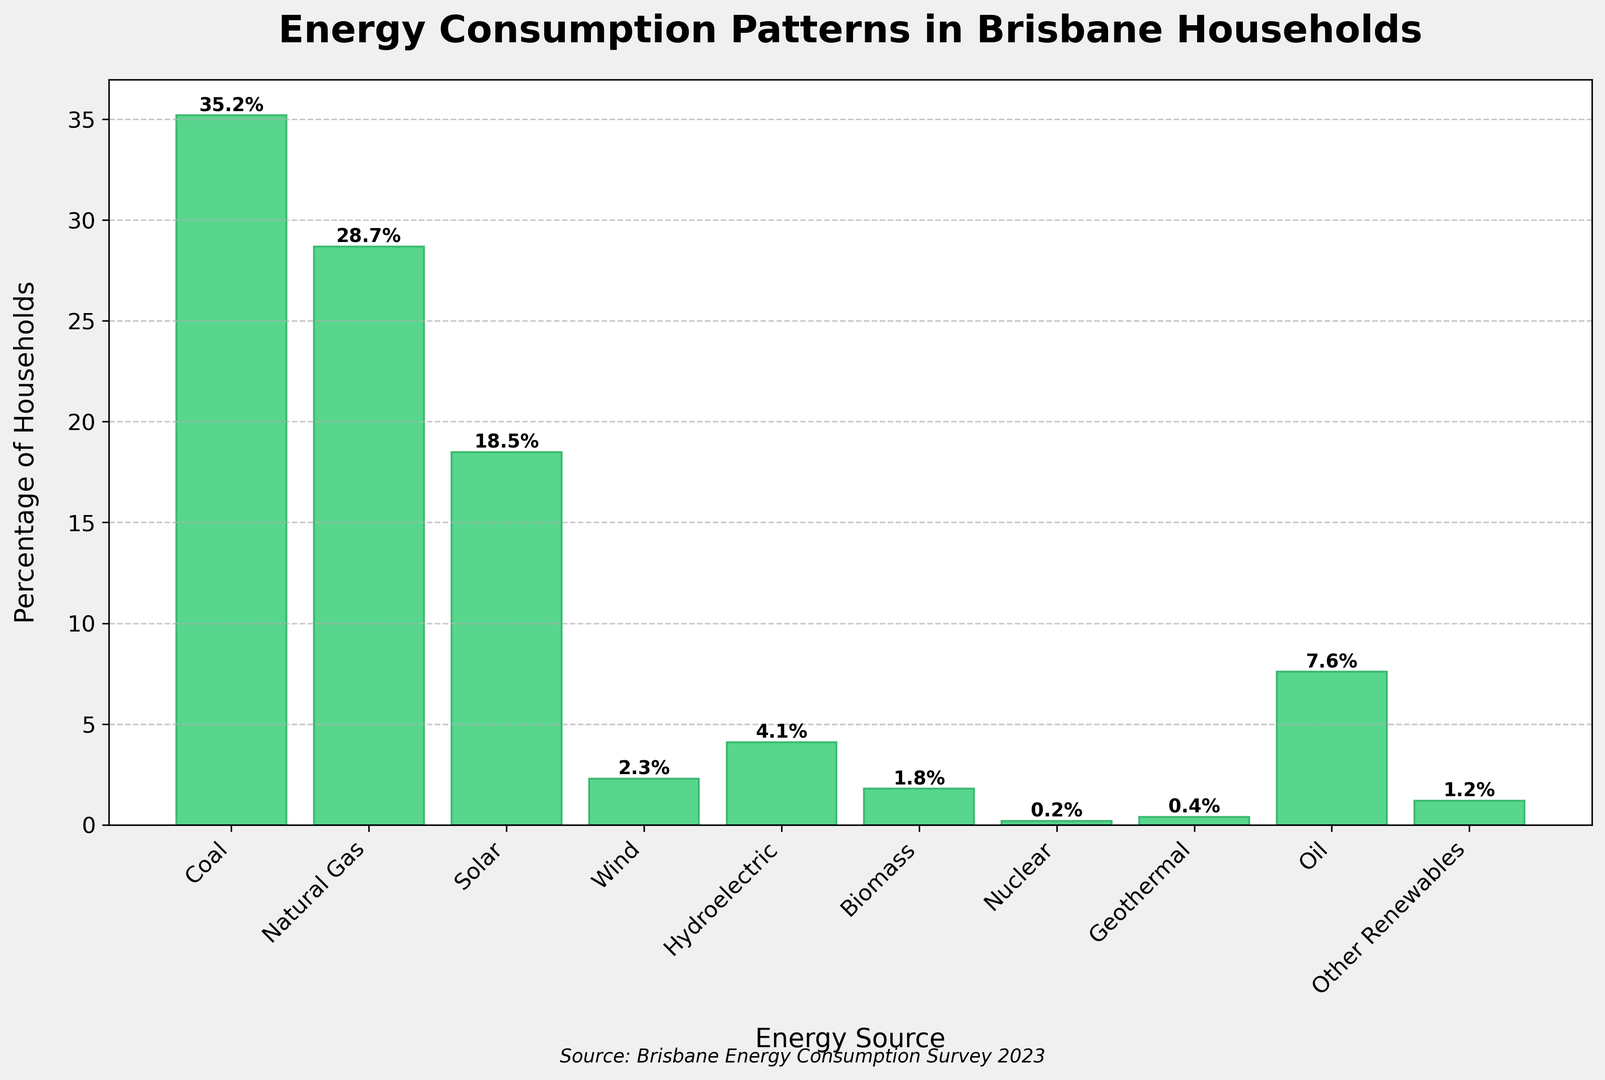Which source has the highest percentage of households? The source with the highest bar in the histogram represents the highest percentage of households. By looking at the graph, coal has the highest bar.
Answer: Coal What is the sum of percentages for renewable energy sources (Solar, Wind, Hydroelectric, Biomass, Geothermal, Other Renewables)? Add the percentages of all renewable sources: Solar (18.5) + Wind (2.3) + Hydroelectric (4.1) + Biomass (1.8) + Geothermal (0.4) + Other Renewables (1.2). The sum is 28.3%.
Answer: 28.3% Which energy source has the lowest percentage of households? The source with the shortest bar represents the lowest percentage of households. By looking at the histogram, Nuclear has the shortest bar.
Answer: Nuclear What is the difference in percentage between households using coal and those using natural gas? Subtract the percentage of households using natural gas from those using coal: 35.2 - 28.7 = 6.5%.
Answer: 6.5% How do the percentages of households using oil compare to those using natural gas? Compare the heights of the bars for oil and natural gas. The oil bar is shorter, indicating a lower percentage. Specifically, oil has 7.6%, while natural gas has 28.7%.
Answer: Oil has a lower percentage than natural gas Which non-renewable energy sources are listed, and what is their collective percentage? Add the percentages of all non-renewable sources: Coal (35.2) + Natural Gas (28.7) + Oil (7.6) + Nuclear (0.2). The sum is 71.7%.
Answer: 71.7% What percentage of households use solar energy, and how does it compare to wind energy usage? Solar energy (18.5%) is far greater than wind energy (2.3%) as observed from the respective bar heights.
Answer: Solar usage is much higher than wind What combination of two energy sources together make up close to 50% of the households? By inspecting the percentages and summing pairs: Coal (35.2) + Solar (18.5) = 53.7% and Coal (35.2) + Natural Gas (28.7) = 63.9%. Therefore, none make exactly 50%, but Coal alone is the closest at 35.2%, followed by Coal + Solar at 53.7%.
Answer: Coal + Solar (53.7%) Between biomass and geothermal, which is used by more households and by how much? Compare their percentages from the histogram: Biomass (1.8%) - Geothermal (0.4%) = 1.4%.
Answer: Biomass by 1.4% What trend can be observed in the use of renewable versus non-renewable energy sources in Brisbane households? By examining the data, non-renewable sources like coal and natural gas have higher percentages compared to renewable ones like solar and wind. The overall trend is higher usage of non-renewable energy sources.
Answer: Non-renewable sources are used more 